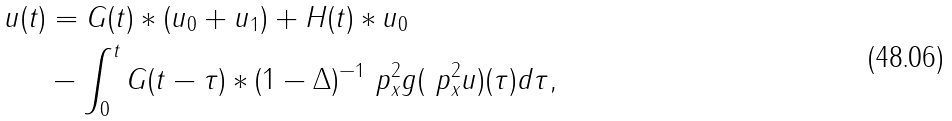<formula> <loc_0><loc_0><loc_500><loc_500>u ( t ) & = G ( t ) \ast ( u _ { 0 } + u _ { 1 } ) + H ( t ) \ast u _ { 0 } \\ & - \int ^ { t } _ { 0 } G ( t - \tau ) \ast ( 1 - \Delta ) ^ { - 1 } \ p ^ { 2 } _ { x } g ( \ p ^ { 2 } _ { x } u ) ( \tau ) d \tau ,</formula> 